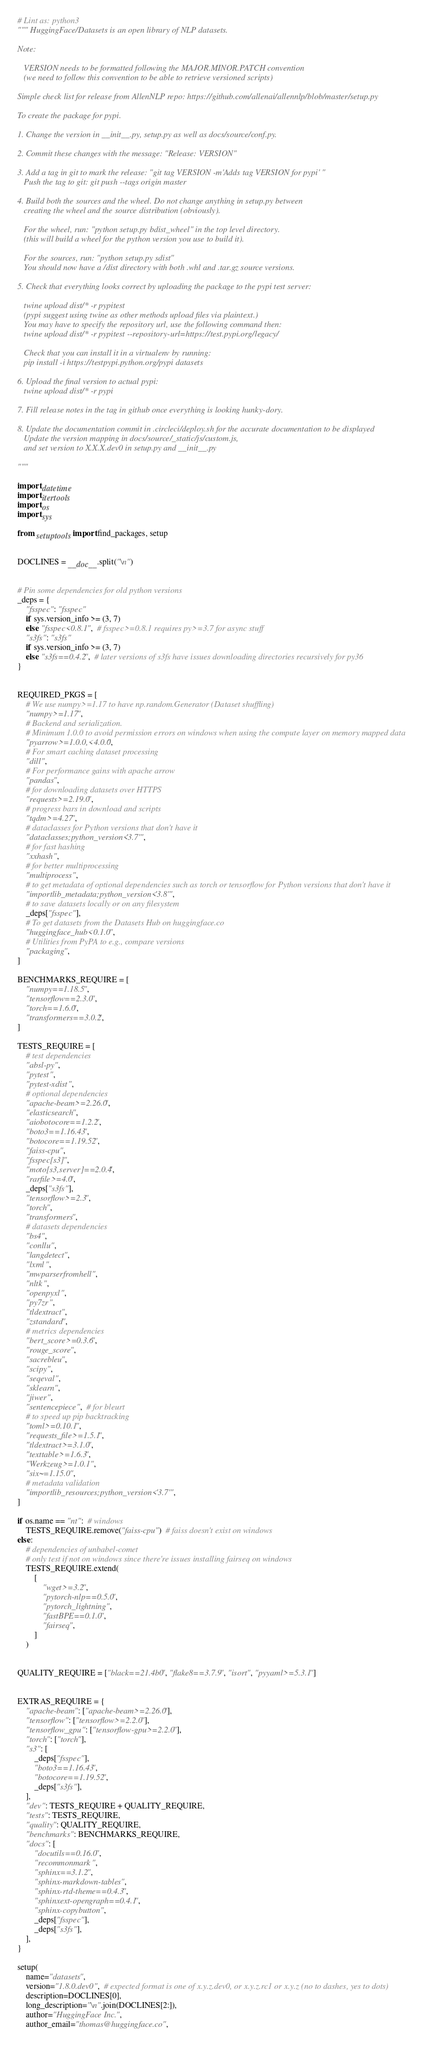<code> <loc_0><loc_0><loc_500><loc_500><_Python_># Lint as: python3
""" HuggingFace/Datasets is an open library of NLP datasets.

Note:

   VERSION needs to be formatted following the MAJOR.MINOR.PATCH convention
   (we need to follow this convention to be able to retrieve versioned scripts)

Simple check list for release from AllenNLP repo: https://github.com/allenai/allennlp/blob/master/setup.py

To create the package for pypi.

1. Change the version in __init__.py, setup.py as well as docs/source/conf.py.

2. Commit these changes with the message: "Release: VERSION"

3. Add a tag in git to mark the release: "git tag VERSION -m'Adds tag VERSION for pypi' "
   Push the tag to git: git push --tags origin master

4. Build both the sources and the wheel. Do not change anything in setup.py between
   creating the wheel and the source distribution (obviously).

   For the wheel, run: "python setup.py bdist_wheel" in the top level directory.
   (this will build a wheel for the python version you use to build it).

   For the sources, run: "python setup.py sdist"
   You should now have a /dist directory with both .whl and .tar.gz source versions.

5. Check that everything looks correct by uploading the package to the pypi test server:

   twine upload dist/* -r pypitest
   (pypi suggest using twine as other methods upload files via plaintext.)
   You may have to specify the repository url, use the following command then:
   twine upload dist/* -r pypitest --repository-url=https://test.pypi.org/legacy/

   Check that you can install it in a virtualenv by running:
   pip install -i https://testpypi.python.org/pypi datasets

6. Upload the final version to actual pypi:
   twine upload dist/* -r pypi

7. Fill release notes in the tag in github once everything is looking hunky-dory.

8. Update the documentation commit in .circleci/deploy.sh for the accurate documentation to be displayed
   Update the version mapping in docs/source/_static/js/custom.js,
   and set version to X.X.X.dev0 in setup.py and __init__.py

"""

import datetime
import itertools
import os
import sys

from setuptools import find_packages, setup


DOCLINES = __doc__.split("\n")


# Pin some dependencies for old python versions
_deps = {
    "fsspec": "fsspec"
    if sys.version_info >= (3, 7)
    else "fsspec<0.8.1",  # fsspec>=0.8.1 requires py>=3.7 for async stuff
    "s3fs": "s3fs"
    if sys.version_info >= (3, 7)
    else "s3fs==0.4.2",  # later versions of s3fs have issues downloading directories recursively for py36
}


REQUIRED_PKGS = [
    # We use numpy>=1.17 to have np.random.Generator (Dataset shuffling)
    "numpy>=1.17",
    # Backend and serialization.
    # Minimum 1.0.0 to avoid permission errors on windows when using the compute layer on memory mapped data
    "pyarrow>=1.0.0,<4.0.0",
    # For smart caching dataset processing
    "dill",
    # For performance gains with apache arrow
    "pandas",
    # for downloading datasets over HTTPS
    "requests>=2.19.0",
    # progress bars in download and scripts
    "tqdm>=4.27",
    # dataclasses for Python versions that don't have it
    "dataclasses;python_version<'3.7'",
    # for fast hashing
    "xxhash",
    # for better multiprocessing
    "multiprocess",
    # to get metadata of optional dependencies such as torch or tensorflow for Python versions that don't have it
    "importlib_metadata;python_version<'3.8'",
    # to save datasets locally or on any filesystem
    _deps["fsspec"],
    # To get datasets from the Datasets Hub on huggingface.co
    "huggingface_hub<0.1.0",
    # Utilities from PyPA to e.g., compare versions
    "packaging",
]

BENCHMARKS_REQUIRE = [
    "numpy==1.18.5",
    "tensorflow==2.3.0",
    "torch==1.6.0",
    "transformers==3.0.2",
]

TESTS_REQUIRE = [
    # test dependencies
    "absl-py",
    "pytest",
    "pytest-xdist",
    # optional dependencies
    "apache-beam>=2.26.0",
    "elasticsearch",
    "aiobotocore==1.2.2",
    "boto3==1.16.43",
    "botocore==1.19.52",
    "faiss-cpu",
    "fsspec[s3]",
    "moto[s3,server]==2.0.4",
    "rarfile>=4.0",
    _deps["s3fs"],
    "tensorflow>=2.3",
    "torch",
    "transformers",
    # datasets dependencies
    "bs4",
    "conllu",
    "langdetect",
    "lxml",
    "mwparserfromhell",
    "nltk",
    "openpyxl",
    "py7zr",
    "tldextract",
    "zstandard",
    # metrics dependencies
    "bert_score>=0.3.6",
    "rouge_score",
    "sacrebleu",
    "scipy",
    "seqeval",
    "sklearn",
    "jiwer",
    "sentencepiece",  # for bleurt
    # to speed up pip backtracking
    "toml>=0.10.1",
    "requests_file>=1.5.1",
    "tldextract>=3.1.0",
    "texttable>=1.6.3",
    "Werkzeug>=1.0.1",
    "six~=1.15.0",
    # metadata validation
    "importlib_resources;python_version<'3.7'",
]

if os.name == "nt":  # windows
    TESTS_REQUIRE.remove("faiss-cpu")  # faiss doesn't exist on windows
else:
    # dependencies of unbabel-comet
    # only test if not on windows since there're issues installing fairseq on windows
    TESTS_REQUIRE.extend(
        [
            "wget>=3.2",
            "pytorch-nlp==0.5.0",
            "pytorch_lightning",
            "fastBPE==0.1.0",
            "fairseq",
        ]
    )


QUALITY_REQUIRE = ["black==21.4b0", "flake8==3.7.9", "isort", "pyyaml>=5.3.1"]


EXTRAS_REQUIRE = {
    "apache-beam": ["apache-beam>=2.26.0"],
    "tensorflow": ["tensorflow>=2.2.0"],
    "tensorflow_gpu": ["tensorflow-gpu>=2.2.0"],
    "torch": ["torch"],
    "s3": [
        _deps["fsspec"],
        "boto3==1.16.43",
        "botocore==1.19.52",
        _deps["s3fs"],
    ],
    "dev": TESTS_REQUIRE + QUALITY_REQUIRE,
    "tests": TESTS_REQUIRE,
    "quality": QUALITY_REQUIRE,
    "benchmarks": BENCHMARKS_REQUIRE,
    "docs": [
        "docutils==0.16.0",
        "recommonmark",
        "sphinx==3.1.2",
        "sphinx-markdown-tables",
        "sphinx-rtd-theme==0.4.3",
        "sphinxext-opengraph==0.4.1",
        "sphinx-copybutton",
        _deps["fsspec"],
        _deps["s3fs"],
    ],
}

setup(
    name="datasets",
    version="1.8.0.dev0",  # expected format is one of x.y.z.dev0, or x.y.z.rc1 or x.y.z (no to dashes, yes to dots)
    description=DOCLINES[0],
    long_description="\n".join(DOCLINES[2:]),
    author="HuggingFace Inc.",
    author_email="thomas@huggingface.co",</code> 